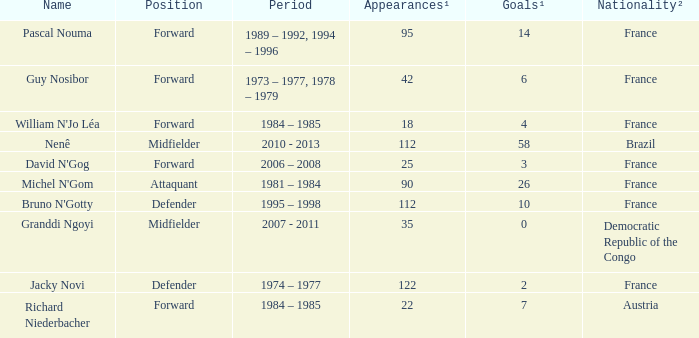List the number of active years for attaquant. 1981 – 1984. 